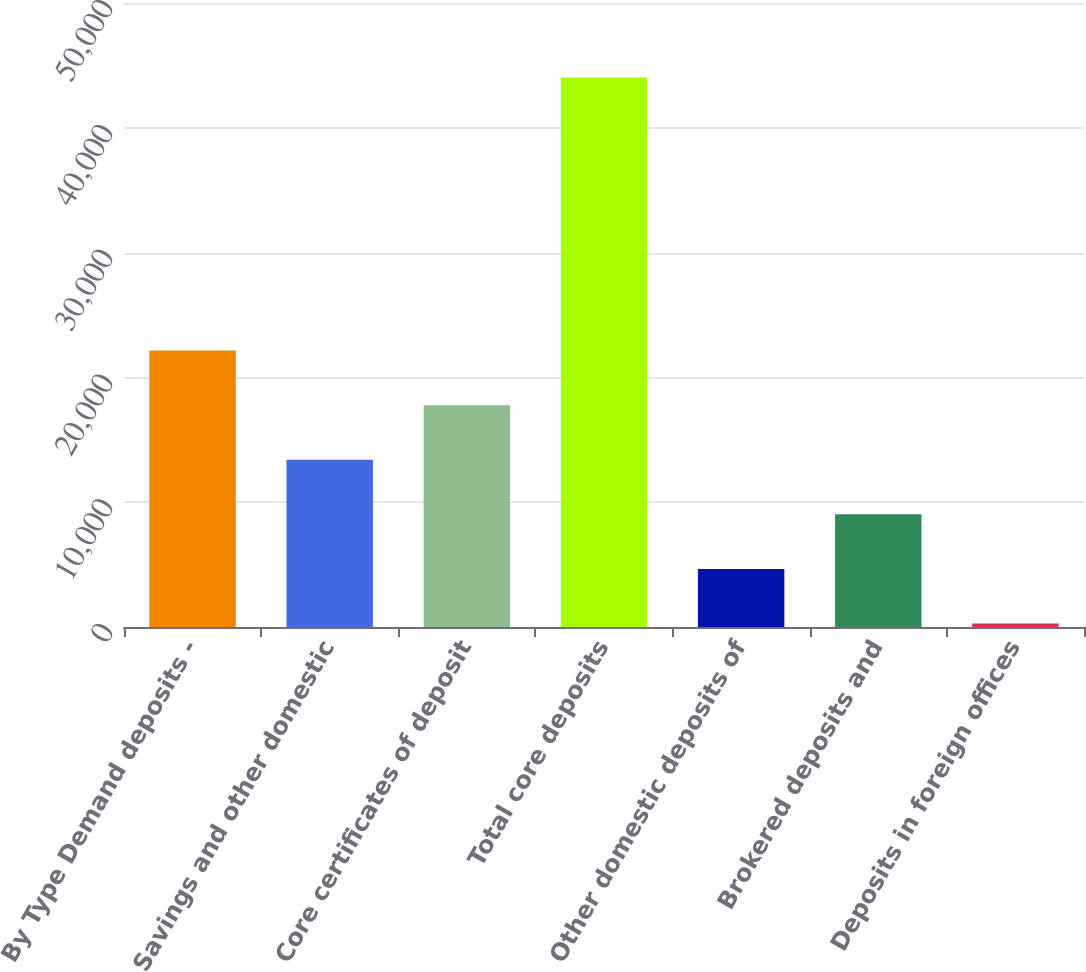Convert chart to OTSL. <chart><loc_0><loc_0><loc_500><loc_500><bar_chart><fcel>By Type Demand deposits -<fcel>Savings and other domestic<fcel>Core certificates of deposit<fcel>Total core deposits<fcel>Other domestic deposits of<fcel>Brokered deposits and<fcel>Deposits in foreign offices<nl><fcel>22152.5<fcel>13402.7<fcel>17777.6<fcel>44027<fcel>4652.9<fcel>9027.8<fcel>278<nl></chart> 